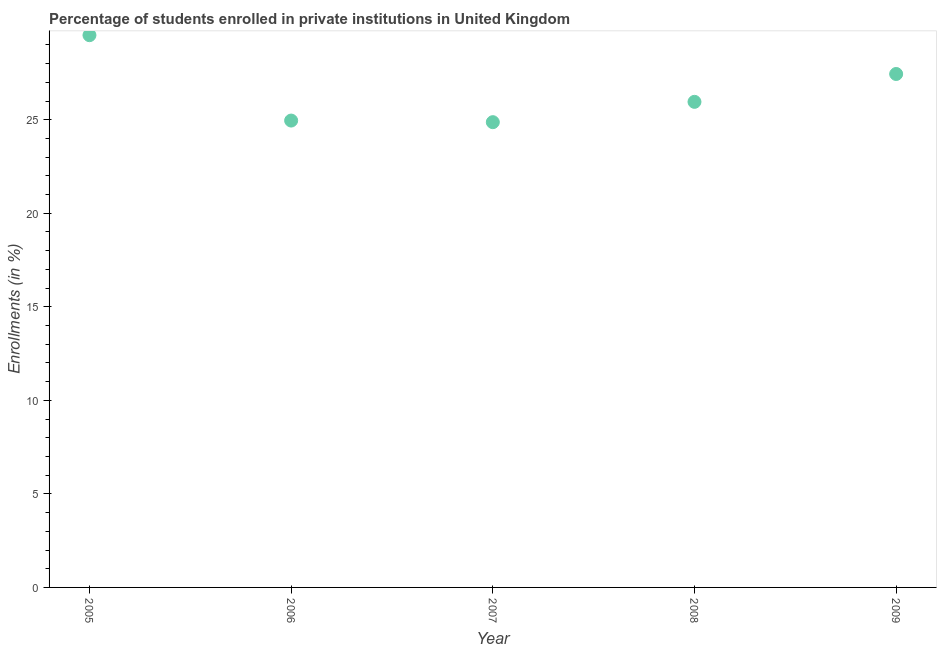What is the enrollments in private institutions in 2008?
Your answer should be very brief. 25.95. Across all years, what is the maximum enrollments in private institutions?
Offer a very short reply. 29.52. Across all years, what is the minimum enrollments in private institutions?
Provide a succinct answer. 24.87. In which year was the enrollments in private institutions minimum?
Your answer should be compact. 2007. What is the sum of the enrollments in private institutions?
Your response must be concise. 132.74. What is the difference between the enrollments in private institutions in 2008 and 2009?
Ensure brevity in your answer.  -1.49. What is the average enrollments in private institutions per year?
Ensure brevity in your answer.  26.55. What is the median enrollments in private institutions?
Offer a terse response. 25.95. What is the ratio of the enrollments in private institutions in 2007 to that in 2008?
Offer a terse response. 0.96. Is the difference between the enrollments in private institutions in 2007 and 2009 greater than the difference between any two years?
Ensure brevity in your answer.  No. What is the difference between the highest and the second highest enrollments in private institutions?
Provide a short and direct response. 2.07. Is the sum of the enrollments in private institutions in 2005 and 2006 greater than the maximum enrollments in private institutions across all years?
Offer a terse response. Yes. What is the difference between the highest and the lowest enrollments in private institutions?
Keep it short and to the point. 4.65. In how many years, is the enrollments in private institutions greater than the average enrollments in private institutions taken over all years?
Offer a terse response. 2. How many dotlines are there?
Your response must be concise. 1. How many years are there in the graph?
Your answer should be very brief. 5. Are the values on the major ticks of Y-axis written in scientific E-notation?
Keep it short and to the point. No. Does the graph contain any zero values?
Keep it short and to the point. No. Does the graph contain grids?
Keep it short and to the point. No. What is the title of the graph?
Offer a terse response. Percentage of students enrolled in private institutions in United Kingdom. What is the label or title of the Y-axis?
Your answer should be very brief. Enrollments (in %). What is the Enrollments (in %) in 2005?
Your answer should be compact. 29.52. What is the Enrollments (in %) in 2006?
Provide a succinct answer. 24.95. What is the Enrollments (in %) in 2007?
Ensure brevity in your answer.  24.87. What is the Enrollments (in %) in 2008?
Offer a very short reply. 25.95. What is the Enrollments (in %) in 2009?
Give a very brief answer. 27.44. What is the difference between the Enrollments (in %) in 2005 and 2006?
Keep it short and to the point. 4.56. What is the difference between the Enrollments (in %) in 2005 and 2007?
Give a very brief answer. 4.65. What is the difference between the Enrollments (in %) in 2005 and 2008?
Your answer should be very brief. 3.56. What is the difference between the Enrollments (in %) in 2005 and 2009?
Your answer should be very brief. 2.07. What is the difference between the Enrollments (in %) in 2006 and 2007?
Offer a terse response. 0.09. What is the difference between the Enrollments (in %) in 2006 and 2009?
Provide a short and direct response. -2.49. What is the difference between the Enrollments (in %) in 2007 and 2008?
Ensure brevity in your answer.  -1.09. What is the difference between the Enrollments (in %) in 2007 and 2009?
Your answer should be compact. -2.58. What is the difference between the Enrollments (in %) in 2008 and 2009?
Provide a short and direct response. -1.49. What is the ratio of the Enrollments (in %) in 2005 to that in 2006?
Your answer should be very brief. 1.18. What is the ratio of the Enrollments (in %) in 2005 to that in 2007?
Your answer should be very brief. 1.19. What is the ratio of the Enrollments (in %) in 2005 to that in 2008?
Provide a succinct answer. 1.14. What is the ratio of the Enrollments (in %) in 2005 to that in 2009?
Provide a succinct answer. 1.08. What is the ratio of the Enrollments (in %) in 2006 to that in 2007?
Your answer should be very brief. 1. What is the ratio of the Enrollments (in %) in 2006 to that in 2008?
Give a very brief answer. 0.96. What is the ratio of the Enrollments (in %) in 2006 to that in 2009?
Keep it short and to the point. 0.91. What is the ratio of the Enrollments (in %) in 2007 to that in 2008?
Provide a succinct answer. 0.96. What is the ratio of the Enrollments (in %) in 2007 to that in 2009?
Give a very brief answer. 0.91. What is the ratio of the Enrollments (in %) in 2008 to that in 2009?
Provide a short and direct response. 0.95. 